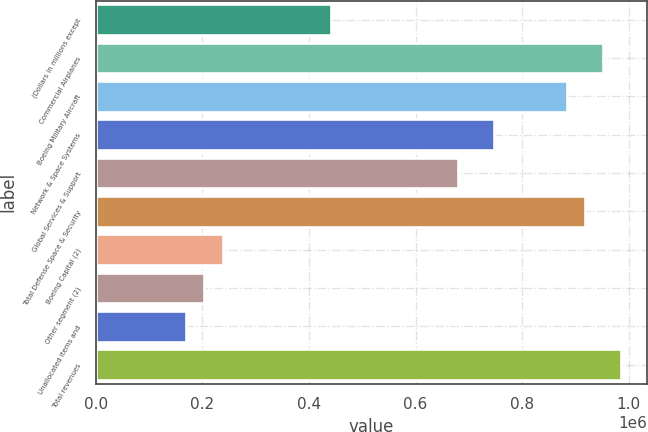Convert chart to OTSL. <chart><loc_0><loc_0><loc_500><loc_500><bar_chart><fcel>(Dollars in millions except<fcel>Commercial Airplanes<fcel>Boeing Military Aircraft<fcel>Network & Space Systems<fcel>Global Services & Support<fcel>Total Defense Space & Security<fcel>Boeing Capital (2)<fcel>Other segment (2)<fcel>Unallocated items and<fcel>Total revenues<nl><fcel>441554<fcel>951037<fcel>883105<fcel>747243<fcel>679312<fcel>917071<fcel>237760<fcel>203795<fcel>169829<fcel>985002<nl></chart> 